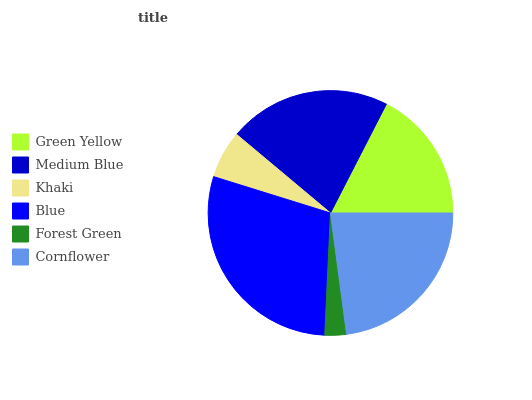Is Forest Green the minimum?
Answer yes or no. Yes. Is Blue the maximum?
Answer yes or no. Yes. Is Medium Blue the minimum?
Answer yes or no. No. Is Medium Blue the maximum?
Answer yes or no. No. Is Medium Blue greater than Green Yellow?
Answer yes or no. Yes. Is Green Yellow less than Medium Blue?
Answer yes or no. Yes. Is Green Yellow greater than Medium Blue?
Answer yes or no. No. Is Medium Blue less than Green Yellow?
Answer yes or no. No. Is Medium Blue the high median?
Answer yes or no. Yes. Is Green Yellow the low median?
Answer yes or no. Yes. Is Cornflower the high median?
Answer yes or no. No. Is Medium Blue the low median?
Answer yes or no. No. 